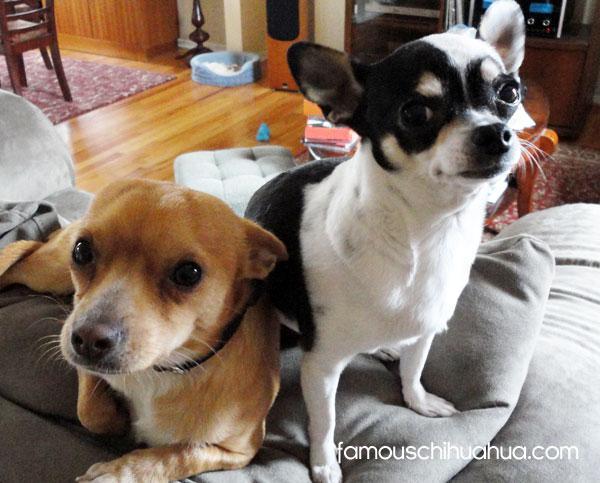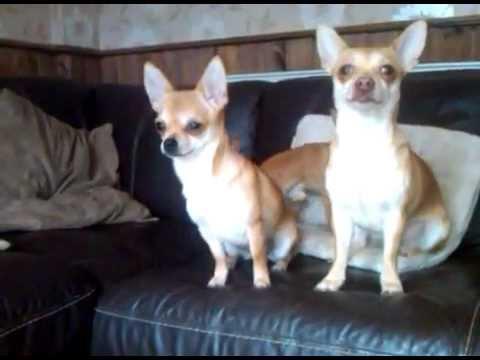The first image is the image on the left, the second image is the image on the right. Assess this claim about the two images: "At least one image shows two similarly colored chihuahuas.". Correct or not? Answer yes or no. Yes. 